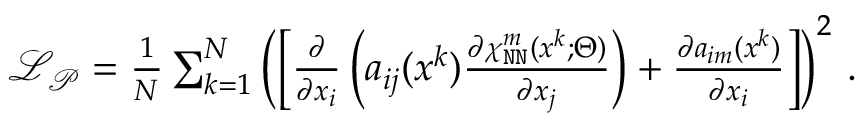<formula> <loc_0><loc_0><loc_500><loc_500>\begin{array} { r } { \mathcal { L } _ { \mathcal { P } } = \frac { 1 } { N } \sum _ { k = 1 } ^ { N } \left ( \left [ \frac { \partial } { \partial x _ { i } } \left ( a _ { i j } ( \boldsymbol x ^ { k } ) \frac { \partial \chi _ { N N } ^ { m } ( \boldsymbol x ^ { k } ; \boldsymbol \Theta ) } { \partial x _ { j } } \right ) + \frac { \partial a _ { i m } ( \boldsymbol x ^ { k } ) } { \partial x _ { i } } \right ] \right ) ^ { 2 } \, . } \end{array}</formula> 